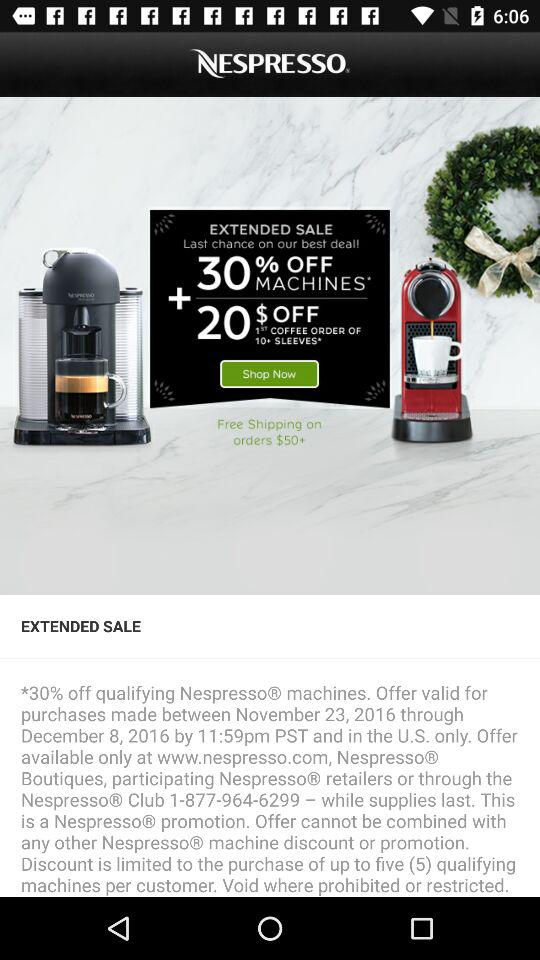What is the name of the application? The name of the application is "NESPRESSO". 